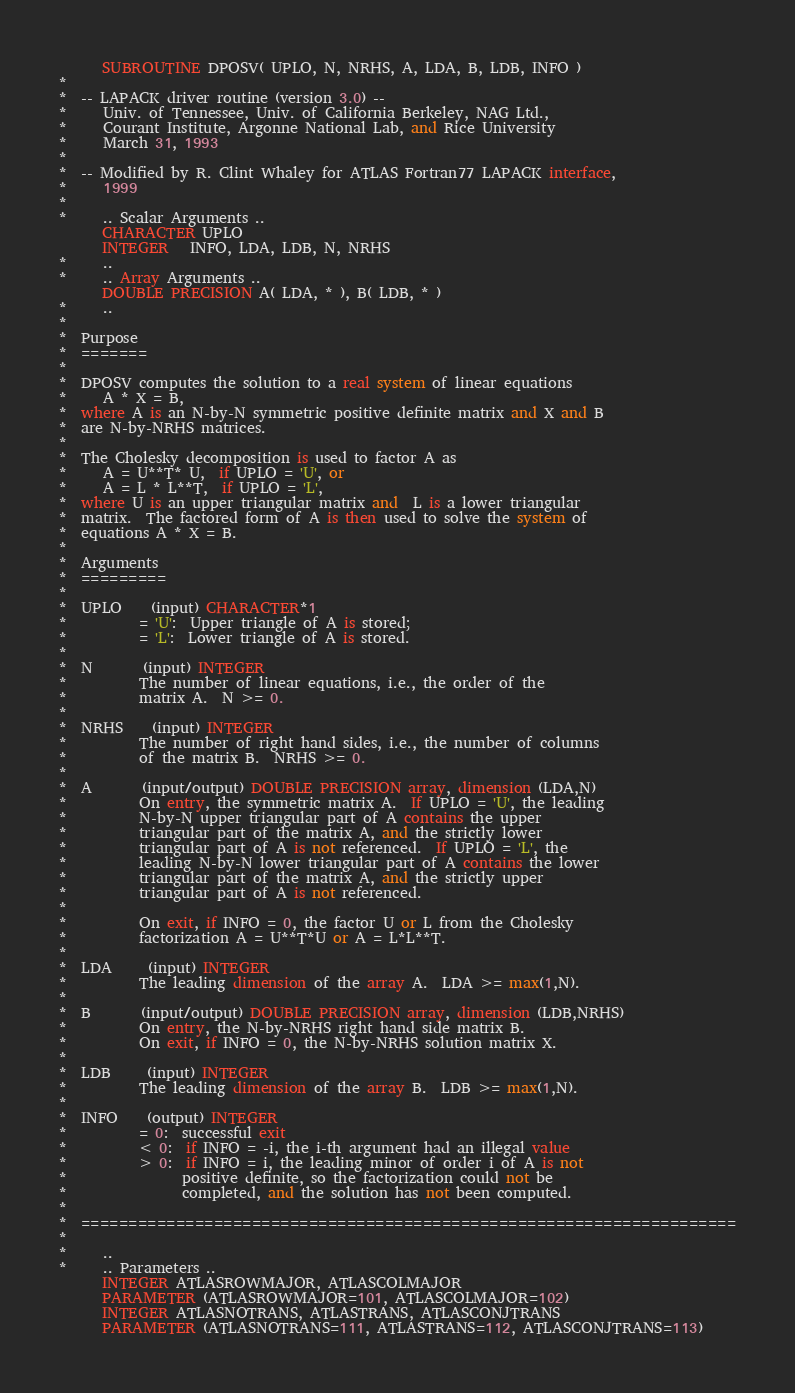<code> <loc_0><loc_0><loc_500><loc_500><_FORTRAN_>      SUBROUTINE DPOSV( UPLO, N, NRHS, A, LDA, B, LDB, INFO )
*
*  -- LAPACK driver routine (version 3.0) --
*     Univ. of Tennessee, Univ. of California Berkeley, NAG Ltd.,
*     Courant Institute, Argonne National Lab, and Rice University
*     March 31, 1993
*
*  -- Modified by R. Clint Whaley for ATLAS Fortran77 LAPACK interface,
*     1999
*
*     .. Scalar Arguments ..
      CHARACTER UPLO
      INTEGER   INFO, LDA, LDB, N, NRHS
*     ..
*     .. Array Arguments ..
      DOUBLE PRECISION A( LDA, * ), B( LDB, * )
*     ..
*
*  Purpose
*  =======
*
*  DPOSV computes the solution to a real system of linear equations
*     A * X = B,
*  where A is an N-by-N symmetric positive definite matrix and X and B
*  are N-by-NRHS matrices.
*
*  The Cholesky decomposition is used to factor A as
*     A = U**T* U,  if UPLO = 'U', or
*     A = L * L**T,  if UPLO = 'L',
*  where U is an upper triangular matrix and  L is a lower triangular
*  matrix.  The factored form of A is then used to solve the system of
*  equations A * X = B.
*
*  Arguments
*  =========
*
*  UPLO    (input) CHARACTER*1
*          = 'U':  Upper triangle of A is stored;
*          = 'L':  Lower triangle of A is stored.
*
*  N       (input) INTEGER
*          The number of linear equations, i.e., the order of the
*          matrix A.  N >= 0.
*
*  NRHS    (input) INTEGER
*          The number of right hand sides, i.e., the number of columns
*          of the matrix B.  NRHS >= 0.
*
*  A       (input/output) DOUBLE PRECISION array, dimension (LDA,N)
*          On entry, the symmetric matrix A.  If UPLO = 'U', the leading
*          N-by-N upper triangular part of A contains the upper
*          triangular part of the matrix A, and the strictly lower
*          triangular part of A is not referenced.  If UPLO = 'L', the
*          leading N-by-N lower triangular part of A contains the lower
*          triangular part of the matrix A, and the strictly upper
*          triangular part of A is not referenced.
*
*          On exit, if INFO = 0, the factor U or L from the Cholesky
*          factorization A = U**T*U or A = L*L**T.
*
*  LDA     (input) INTEGER
*          The leading dimension of the array A.  LDA >= max(1,N).
*
*  B       (input/output) DOUBLE PRECISION array, dimension (LDB,NRHS)
*          On entry, the N-by-NRHS right hand side matrix B.
*          On exit, if INFO = 0, the N-by-NRHS solution matrix X.
*
*  LDB     (input) INTEGER
*          The leading dimension of the array B.  LDB >= max(1,N).
*
*  INFO    (output) INTEGER
*          = 0:  successful exit
*          < 0:  if INFO = -i, the i-th argument had an illegal value
*          > 0:  if INFO = i, the leading minor of order i of A is not
*                positive definite, so the factorization could not be
*                completed, and the solution has not been computed.
*
*  =====================================================================
*
*     ..
*     .. Parameters ..
      INTEGER ATLASROWMAJOR, ATLASCOLMAJOR
      PARAMETER (ATLASROWMAJOR=101, ATLASCOLMAJOR=102)
      INTEGER ATLASNOTRANS, ATLASTRANS, ATLASCONJTRANS
      PARAMETER (ATLASNOTRANS=111, ATLASTRANS=112, ATLASCONJTRANS=113)</code> 